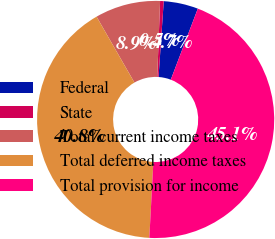Convert chart to OTSL. <chart><loc_0><loc_0><loc_500><loc_500><pie_chart><fcel>Federal<fcel>State<fcel>Total current income taxes<fcel>Total deferred income taxes<fcel>Total provision for income<nl><fcel>4.7%<fcel>0.49%<fcel>8.9%<fcel>40.85%<fcel>45.06%<nl></chart> 